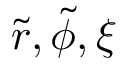<formula> <loc_0><loc_0><loc_500><loc_500>\tilde { r } , \tilde { \phi } , \xi</formula> 